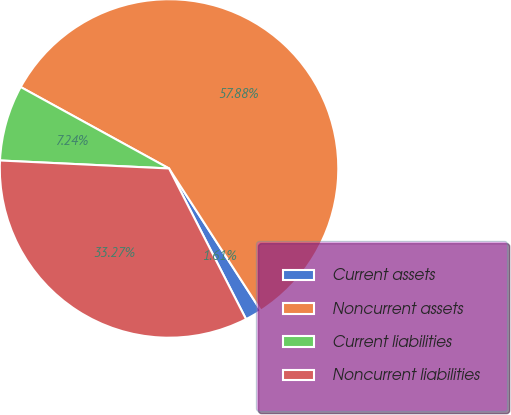Convert chart to OTSL. <chart><loc_0><loc_0><loc_500><loc_500><pie_chart><fcel>Current assets<fcel>Noncurrent assets<fcel>Current liabilities<fcel>Noncurrent liabilities<nl><fcel>1.61%<fcel>57.88%<fcel>7.24%<fcel>33.27%<nl></chart> 